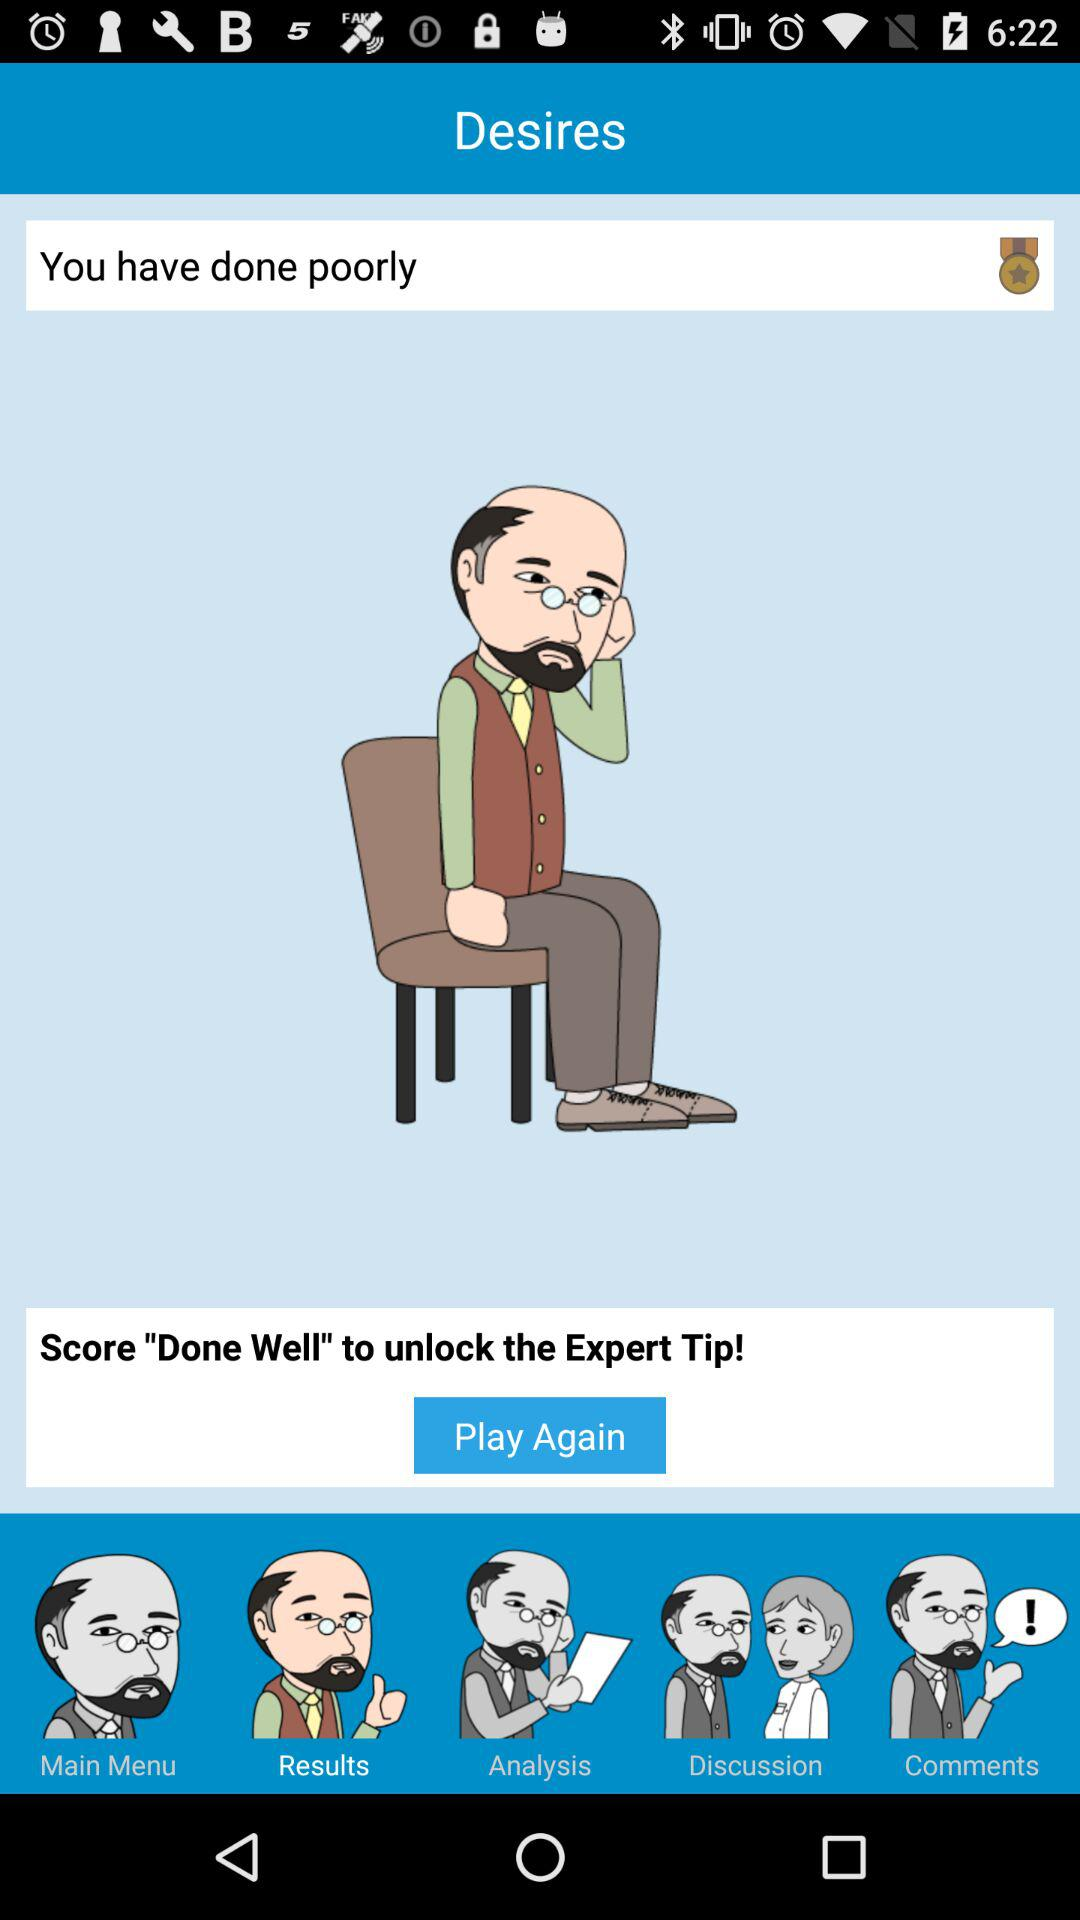What is the review?
When the provided information is insufficient, respond with <no answer>. <no answer> 